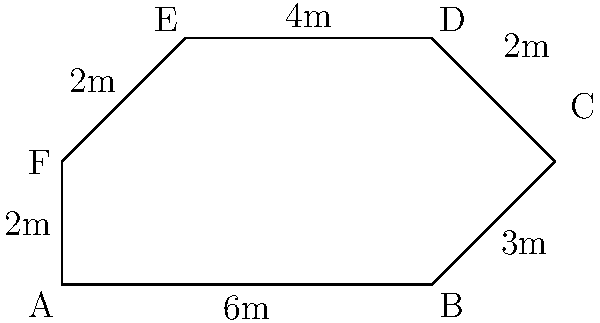You're planning a film set layout for an upcoming production. The set is shaped like an irregular hexagon, as shown in the diagram. Calculate the perimeter of the film set to determine the amount of temporary fencing needed for security purposes. All measurements are in meters. To calculate the perimeter of the irregular hexagon-shaped film set, we need to sum up the lengths of all sides:

1. Side AB: $6$ meters
2. Side BC: $3$ meters
3. Side CD: $2$ meters
4. Side DE: $4$ meters
5. Side EF: $2$ meters
6. Side FA: $2$ meters

Now, let's add all these lengths:

$$\text{Perimeter} = 6 + 3 + 2 + 4 + 2 + 2 = 19$$

Therefore, the perimeter of the film set is 19 meters.
Answer: 19 meters 